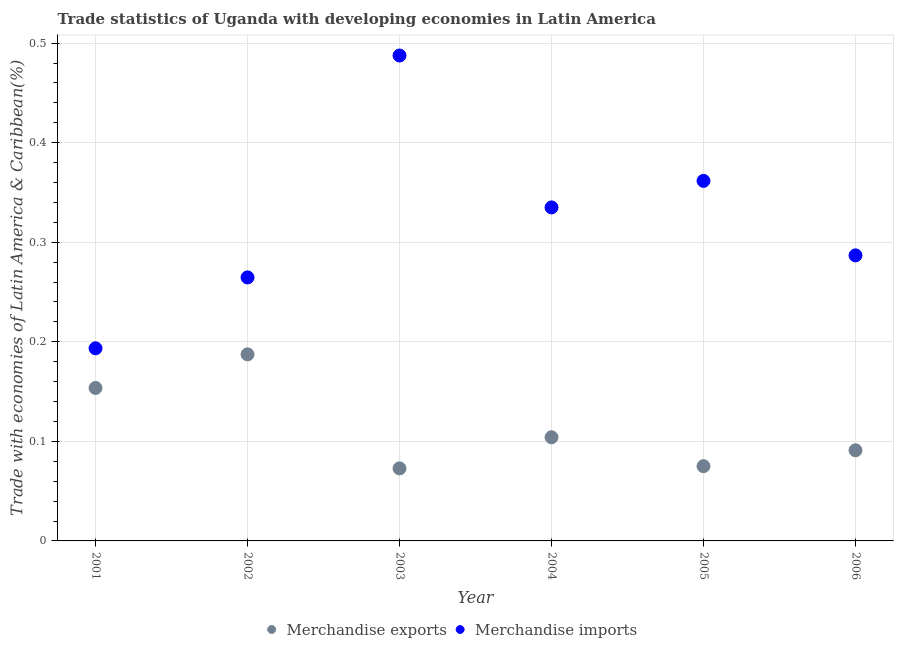How many different coloured dotlines are there?
Offer a terse response. 2. What is the merchandise imports in 2003?
Offer a terse response. 0.49. Across all years, what is the maximum merchandise exports?
Offer a very short reply. 0.19. Across all years, what is the minimum merchandise imports?
Provide a short and direct response. 0.19. In which year was the merchandise imports maximum?
Provide a short and direct response. 2003. In which year was the merchandise imports minimum?
Provide a short and direct response. 2001. What is the total merchandise exports in the graph?
Provide a succinct answer. 0.68. What is the difference between the merchandise imports in 2002 and that in 2003?
Offer a very short reply. -0.22. What is the difference between the merchandise imports in 2003 and the merchandise exports in 2004?
Your response must be concise. 0.38. What is the average merchandise exports per year?
Provide a succinct answer. 0.11. In the year 2004, what is the difference between the merchandise exports and merchandise imports?
Make the answer very short. -0.23. What is the ratio of the merchandise imports in 2001 to that in 2002?
Provide a succinct answer. 0.73. Is the merchandise exports in 2001 less than that in 2006?
Offer a very short reply. No. What is the difference between the highest and the second highest merchandise exports?
Provide a succinct answer. 0.03. What is the difference between the highest and the lowest merchandise imports?
Provide a succinct answer. 0.29. In how many years, is the merchandise imports greater than the average merchandise imports taken over all years?
Make the answer very short. 3. Is the merchandise imports strictly less than the merchandise exports over the years?
Offer a terse response. No. How many years are there in the graph?
Your answer should be compact. 6. What is the difference between two consecutive major ticks on the Y-axis?
Your answer should be compact. 0.1. Are the values on the major ticks of Y-axis written in scientific E-notation?
Offer a terse response. No. What is the title of the graph?
Offer a very short reply. Trade statistics of Uganda with developing economies in Latin America. What is the label or title of the X-axis?
Provide a short and direct response. Year. What is the label or title of the Y-axis?
Your answer should be very brief. Trade with economies of Latin America & Caribbean(%). What is the Trade with economies of Latin America & Caribbean(%) in Merchandise exports in 2001?
Provide a succinct answer. 0.15. What is the Trade with economies of Latin America & Caribbean(%) in Merchandise imports in 2001?
Provide a short and direct response. 0.19. What is the Trade with economies of Latin America & Caribbean(%) of Merchandise exports in 2002?
Your answer should be very brief. 0.19. What is the Trade with economies of Latin America & Caribbean(%) of Merchandise imports in 2002?
Give a very brief answer. 0.26. What is the Trade with economies of Latin America & Caribbean(%) of Merchandise exports in 2003?
Provide a succinct answer. 0.07. What is the Trade with economies of Latin America & Caribbean(%) of Merchandise imports in 2003?
Offer a very short reply. 0.49. What is the Trade with economies of Latin America & Caribbean(%) in Merchandise exports in 2004?
Provide a succinct answer. 0.1. What is the Trade with economies of Latin America & Caribbean(%) in Merchandise imports in 2004?
Provide a short and direct response. 0.33. What is the Trade with economies of Latin America & Caribbean(%) in Merchandise exports in 2005?
Offer a terse response. 0.08. What is the Trade with economies of Latin America & Caribbean(%) in Merchandise imports in 2005?
Your response must be concise. 0.36. What is the Trade with economies of Latin America & Caribbean(%) in Merchandise exports in 2006?
Your response must be concise. 0.09. What is the Trade with economies of Latin America & Caribbean(%) in Merchandise imports in 2006?
Your answer should be compact. 0.29. Across all years, what is the maximum Trade with economies of Latin America & Caribbean(%) in Merchandise exports?
Your response must be concise. 0.19. Across all years, what is the maximum Trade with economies of Latin America & Caribbean(%) in Merchandise imports?
Keep it short and to the point. 0.49. Across all years, what is the minimum Trade with economies of Latin America & Caribbean(%) of Merchandise exports?
Offer a very short reply. 0.07. Across all years, what is the minimum Trade with economies of Latin America & Caribbean(%) of Merchandise imports?
Ensure brevity in your answer.  0.19. What is the total Trade with economies of Latin America & Caribbean(%) in Merchandise exports in the graph?
Ensure brevity in your answer.  0.68. What is the total Trade with economies of Latin America & Caribbean(%) of Merchandise imports in the graph?
Your answer should be compact. 1.93. What is the difference between the Trade with economies of Latin America & Caribbean(%) in Merchandise exports in 2001 and that in 2002?
Offer a very short reply. -0.03. What is the difference between the Trade with economies of Latin America & Caribbean(%) in Merchandise imports in 2001 and that in 2002?
Give a very brief answer. -0.07. What is the difference between the Trade with economies of Latin America & Caribbean(%) of Merchandise exports in 2001 and that in 2003?
Provide a short and direct response. 0.08. What is the difference between the Trade with economies of Latin America & Caribbean(%) of Merchandise imports in 2001 and that in 2003?
Your answer should be very brief. -0.29. What is the difference between the Trade with economies of Latin America & Caribbean(%) in Merchandise exports in 2001 and that in 2004?
Make the answer very short. 0.05. What is the difference between the Trade with economies of Latin America & Caribbean(%) of Merchandise imports in 2001 and that in 2004?
Your answer should be compact. -0.14. What is the difference between the Trade with economies of Latin America & Caribbean(%) of Merchandise exports in 2001 and that in 2005?
Provide a succinct answer. 0.08. What is the difference between the Trade with economies of Latin America & Caribbean(%) of Merchandise imports in 2001 and that in 2005?
Offer a terse response. -0.17. What is the difference between the Trade with economies of Latin America & Caribbean(%) in Merchandise exports in 2001 and that in 2006?
Your answer should be compact. 0.06. What is the difference between the Trade with economies of Latin America & Caribbean(%) of Merchandise imports in 2001 and that in 2006?
Offer a very short reply. -0.09. What is the difference between the Trade with economies of Latin America & Caribbean(%) in Merchandise exports in 2002 and that in 2003?
Ensure brevity in your answer.  0.11. What is the difference between the Trade with economies of Latin America & Caribbean(%) in Merchandise imports in 2002 and that in 2003?
Make the answer very short. -0.22. What is the difference between the Trade with economies of Latin America & Caribbean(%) in Merchandise exports in 2002 and that in 2004?
Keep it short and to the point. 0.08. What is the difference between the Trade with economies of Latin America & Caribbean(%) of Merchandise imports in 2002 and that in 2004?
Provide a succinct answer. -0.07. What is the difference between the Trade with economies of Latin America & Caribbean(%) of Merchandise exports in 2002 and that in 2005?
Your answer should be compact. 0.11. What is the difference between the Trade with economies of Latin America & Caribbean(%) in Merchandise imports in 2002 and that in 2005?
Provide a short and direct response. -0.1. What is the difference between the Trade with economies of Latin America & Caribbean(%) in Merchandise exports in 2002 and that in 2006?
Ensure brevity in your answer.  0.1. What is the difference between the Trade with economies of Latin America & Caribbean(%) of Merchandise imports in 2002 and that in 2006?
Provide a short and direct response. -0.02. What is the difference between the Trade with economies of Latin America & Caribbean(%) of Merchandise exports in 2003 and that in 2004?
Your response must be concise. -0.03. What is the difference between the Trade with economies of Latin America & Caribbean(%) in Merchandise imports in 2003 and that in 2004?
Keep it short and to the point. 0.15. What is the difference between the Trade with economies of Latin America & Caribbean(%) in Merchandise exports in 2003 and that in 2005?
Your answer should be compact. -0. What is the difference between the Trade with economies of Latin America & Caribbean(%) of Merchandise imports in 2003 and that in 2005?
Provide a short and direct response. 0.13. What is the difference between the Trade with economies of Latin America & Caribbean(%) of Merchandise exports in 2003 and that in 2006?
Keep it short and to the point. -0.02. What is the difference between the Trade with economies of Latin America & Caribbean(%) in Merchandise imports in 2003 and that in 2006?
Offer a terse response. 0.2. What is the difference between the Trade with economies of Latin America & Caribbean(%) of Merchandise exports in 2004 and that in 2005?
Keep it short and to the point. 0.03. What is the difference between the Trade with economies of Latin America & Caribbean(%) in Merchandise imports in 2004 and that in 2005?
Give a very brief answer. -0.03. What is the difference between the Trade with economies of Latin America & Caribbean(%) of Merchandise exports in 2004 and that in 2006?
Provide a short and direct response. 0.01. What is the difference between the Trade with economies of Latin America & Caribbean(%) of Merchandise imports in 2004 and that in 2006?
Offer a terse response. 0.05. What is the difference between the Trade with economies of Latin America & Caribbean(%) of Merchandise exports in 2005 and that in 2006?
Give a very brief answer. -0.02. What is the difference between the Trade with economies of Latin America & Caribbean(%) of Merchandise imports in 2005 and that in 2006?
Your response must be concise. 0.07. What is the difference between the Trade with economies of Latin America & Caribbean(%) in Merchandise exports in 2001 and the Trade with economies of Latin America & Caribbean(%) in Merchandise imports in 2002?
Your answer should be compact. -0.11. What is the difference between the Trade with economies of Latin America & Caribbean(%) in Merchandise exports in 2001 and the Trade with economies of Latin America & Caribbean(%) in Merchandise imports in 2003?
Provide a short and direct response. -0.33. What is the difference between the Trade with economies of Latin America & Caribbean(%) in Merchandise exports in 2001 and the Trade with economies of Latin America & Caribbean(%) in Merchandise imports in 2004?
Your response must be concise. -0.18. What is the difference between the Trade with economies of Latin America & Caribbean(%) of Merchandise exports in 2001 and the Trade with economies of Latin America & Caribbean(%) of Merchandise imports in 2005?
Offer a terse response. -0.21. What is the difference between the Trade with economies of Latin America & Caribbean(%) of Merchandise exports in 2001 and the Trade with economies of Latin America & Caribbean(%) of Merchandise imports in 2006?
Make the answer very short. -0.13. What is the difference between the Trade with economies of Latin America & Caribbean(%) in Merchandise exports in 2002 and the Trade with economies of Latin America & Caribbean(%) in Merchandise imports in 2003?
Provide a short and direct response. -0.3. What is the difference between the Trade with economies of Latin America & Caribbean(%) in Merchandise exports in 2002 and the Trade with economies of Latin America & Caribbean(%) in Merchandise imports in 2004?
Ensure brevity in your answer.  -0.15. What is the difference between the Trade with economies of Latin America & Caribbean(%) in Merchandise exports in 2002 and the Trade with economies of Latin America & Caribbean(%) in Merchandise imports in 2005?
Provide a succinct answer. -0.17. What is the difference between the Trade with economies of Latin America & Caribbean(%) of Merchandise exports in 2002 and the Trade with economies of Latin America & Caribbean(%) of Merchandise imports in 2006?
Provide a succinct answer. -0.1. What is the difference between the Trade with economies of Latin America & Caribbean(%) of Merchandise exports in 2003 and the Trade with economies of Latin America & Caribbean(%) of Merchandise imports in 2004?
Offer a very short reply. -0.26. What is the difference between the Trade with economies of Latin America & Caribbean(%) of Merchandise exports in 2003 and the Trade with economies of Latin America & Caribbean(%) of Merchandise imports in 2005?
Offer a very short reply. -0.29. What is the difference between the Trade with economies of Latin America & Caribbean(%) of Merchandise exports in 2003 and the Trade with economies of Latin America & Caribbean(%) of Merchandise imports in 2006?
Your answer should be compact. -0.21. What is the difference between the Trade with economies of Latin America & Caribbean(%) of Merchandise exports in 2004 and the Trade with economies of Latin America & Caribbean(%) of Merchandise imports in 2005?
Your response must be concise. -0.26. What is the difference between the Trade with economies of Latin America & Caribbean(%) in Merchandise exports in 2004 and the Trade with economies of Latin America & Caribbean(%) in Merchandise imports in 2006?
Offer a very short reply. -0.18. What is the difference between the Trade with economies of Latin America & Caribbean(%) of Merchandise exports in 2005 and the Trade with economies of Latin America & Caribbean(%) of Merchandise imports in 2006?
Make the answer very short. -0.21. What is the average Trade with economies of Latin America & Caribbean(%) in Merchandise exports per year?
Provide a succinct answer. 0.11. What is the average Trade with economies of Latin America & Caribbean(%) in Merchandise imports per year?
Give a very brief answer. 0.32. In the year 2001, what is the difference between the Trade with economies of Latin America & Caribbean(%) in Merchandise exports and Trade with economies of Latin America & Caribbean(%) in Merchandise imports?
Provide a succinct answer. -0.04. In the year 2002, what is the difference between the Trade with economies of Latin America & Caribbean(%) of Merchandise exports and Trade with economies of Latin America & Caribbean(%) of Merchandise imports?
Offer a terse response. -0.08. In the year 2003, what is the difference between the Trade with economies of Latin America & Caribbean(%) in Merchandise exports and Trade with economies of Latin America & Caribbean(%) in Merchandise imports?
Offer a very short reply. -0.41. In the year 2004, what is the difference between the Trade with economies of Latin America & Caribbean(%) of Merchandise exports and Trade with economies of Latin America & Caribbean(%) of Merchandise imports?
Your response must be concise. -0.23. In the year 2005, what is the difference between the Trade with economies of Latin America & Caribbean(%) in Merchandise exports and Trade with economies of Latin America & Caribbean(%) in Merchandise imports?
Your response must be concise. -0.29. In the year 2006, what is the difference between the Trade with economies of Latin America & Caribbean(%) of Merchandise exports and Trade with economies of Latin America & Caribbean(%) of Merchandise imports?
Make the answer very short. -0.2. What is the ratio of the Trade with economies of Latin America & Caribbean(%) in Merchandise exports in 2001 to that in 2002?
Make the answer very short. 0.82. What is the ratio of the Trade with economies of Latin America & Caribbean(%) of Merchandise imports in 2001 to that in 2002?
Ensure brevity in your answer.  0.73. What is the ratio of the Trade with economies of Latin America & Caribbean(%) in Merchandise exports in 2001 to that in 2003?
Give a very brief answer. 2.11. What is the ratio of the Trade with economies of Latin America & Caribbean(%) in Merchandise imports in 2001 to that in 2003?
Ensure brevity in your answer.  0.4. What is the ratio of the Trade with economies of Latin America & Caribbean(%) in Merchandise exports in 2001 to that in 2004?
Provide a short and direct response. 1.48. What is the ratio of the Trade with economies of Latin America & Caribbean(%) of Merchandise imports in 2001 to that in 2004?
Your answer should be very brief. 0.58. What is the ratio of the Trade with economies of Latin America & Caribbean(%) in Merchandise exports in 2001 to that in 2005?
Your answer should be very brief. 2.05. What is the ratio of the Trade with economies of Latin America & Caribbean(%) in Merchandise imports in 2001 to that in 2005?
Ensure brevity in your answer.  0.54. What is the ratio of the Trade with economies of Latin America & Caribbean(%) of Merchandise exports in 2001 to that in 2006?
Your response must be concise. 1.69. What is the ratio of the Trade with economies of Latin America & Caribbean(%) in Merchandise imports in 2001 to that in 2006?
Your answer should be compact. 0.67. What is the ratio of the Trade with economies of Latin America & Caribbean(%) in Merchandise exports in 2002 to that in 2003?
Your answer should be very brief. 2.57. What is the ratio of the Trade with economies of Latin America & Caribbean(%) in Merchandise imports in 2002 to that in 2003?
Offer a very short reply. 0.54. What is the ratio of the Trade with economies of Latin America & Caribbean(%) in Merchandise exports in 2002 to that in 2004?
Keep it short and to the point. 1.8. What is the ratio of the Trade with economies of Latin America & Caribbean(%) of Merchandise imports in 2002 to that in 2004?
Your response must be concise. 0.79. What is the ratio of the Trade with economies of Latin America & Caribbean(%) in Merchandise exports in 2002 to that in 2005?
Offer a terse response. 2.5. What is the ratio of the Trade with economies of Latin America & Caribbean(%) in Merchandise imports in 2002 to that in 2005?
Provide a short and direct response. 0.73. What is the ratio of the Trade with economies of Latin America & Caribbean(%) of Merchandise exports in 2002 to that in 2006?
Provide a short and direct response. 2.06. What is the ratio of the Trade with economies of Latin America & Caribbean(%) in Merchandise imports in 2002 to that in 2006?
Your answer should be compact. 0.92. What is the ratio of the Trade with economies of Latin America & Caribbean(%) in Merchandise exports in 2003 to that in 2004?
Your answer should be compact. 0.7. What is the ratio of the Trade with economies of Latin America & Caribbean(%) in Merchandise imports in 2003 to that in 2004?
Your answer should be very brief. 1.46. What is the ratio of the Trade with economies of Latin America & Caribbean(%) in Merchandise exports in 2003 to that in 2005?
Make the answer very short. 0.97. What is the ratio of the Trade with economies of Latin America & Caribbean(%) in Merchandise imports in 2003 to that in 2005?
Provide a short and direct response. 1.35. What is the ratio of the Trade with economies of Latin America & Caribbean(%) of Merchandise exports in 2003 to that in 2006?
Provide a short and direct response. 0.8. What is the ratio of the Trade with economies of Latin America & Caribbean(%) in Merchandise imports in 2003 to that in 2006?
Provide a succinct answer. 1.7. What is the ratio of the Trade with economies of Latin America & Caribbean(%) in Merchandise exports in 2004 to that in 2005?
Your answer should be compact. 1.39. What is the ratio of the Trade with economies of Latin America & Caribbean(%) in Merchandise imports in 2004 to that in 2005?
Your answer should be compact. 0.93. What is the ratio of the Trade with economies of Latin America & Caribbean(%) of Merchandise exports in 2004 to that in 2006?
Your answer should be compact. 1.14. What is the ratio of the Trade with economies of Latin America & Caribbean(%) of Merchandise imports in 2004 to that in 2006?
Make the answer very short. 1.17. What is the ratio of the Trade with economies of Latin America & Caribbean(%) in Merchandise exports in 2005 to that in 2006?
Your answer should be compact. 0.82. What is the ratio of the Trade with economies of Latin America & Caribbean(%) of Merchandise imports in 2005 to that in 2006?
Your response must be concise. 1.26. What is the difference between the highest and the second highest Trade with economies of Latin America & Caribbean(%) in Merchandise exports?
Offer a very short reply. 0.03. What is the difference between the highest and the second highest Trade with economies of Latin America & Caribbean(%) of Merchandise imports?
Ensure brevity in your answer.  0.13. What is the difference between the highest and the lowest Trade with economies of Latin America & Caribbean(%) of Merchandise exports?
Offer a very short reply. 0.11. What is the difference between the highest and the lowest Trade with economies of Latin America & Caribbean(%) of Merchandise imports?
Make the answer very short. 0.29. 